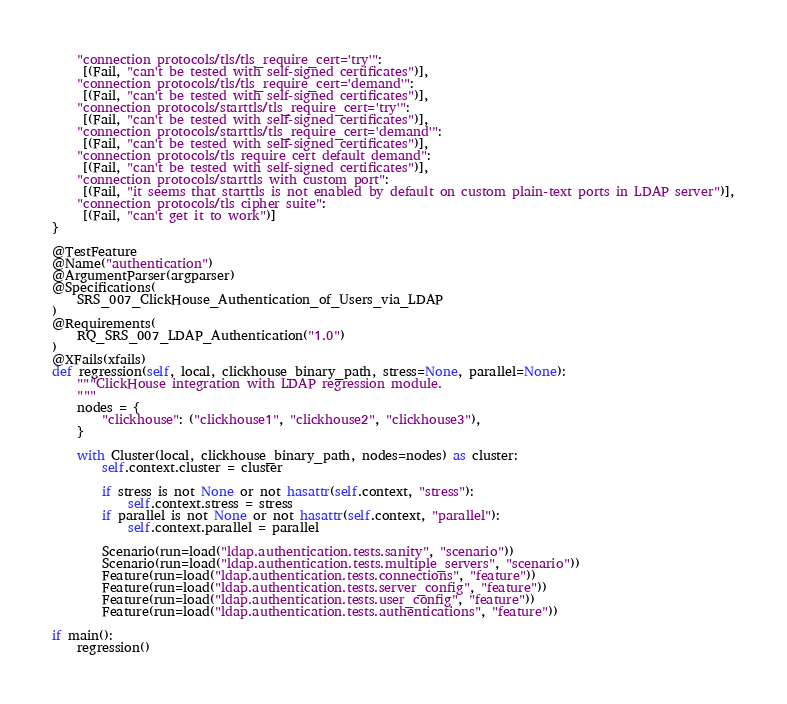<code> <loc_0><loc_0><loc_500><loc_500><_Python_>    "connection protocols/tls/tls_require_cert='try'":
     [(Fail, "can't be tested with self-signed certificates")],
    "connection protocols/tls/tls_require_cert='demand'":
     [(Fail, "can't be tested with self-signed certificates")],
    "connection protocols/starttls/tls_require_cert='try'":
     [(Fail, "can't be tested with self-signed certificates")],
    "connection protocols/starttls/tls_require_cert='demand'":
     [(Fail, "can't be tested with self-signed certificates")],
    "connection protocols/tls require cert default demand":
     [(Fail, "can't be tested with self-signed certificates")],
    "connection protocols/starttls with custom port":
     [(Fail, "it seems that starttls is not enabled by default on custom plain-text ports in LDAP server")],
    "connection protocols/tls cipher suite":
     [(Fail, "can't get it to work")]
}

@TestFeature
@Name("authentication")
@ArgumentParser(argparser)
@Specifications(
    SRS_007_ClickHouse_Authentication_of_Users_via_LDAP
)
@Requirements(
    RQ_SRS_007_LDAP_Authentication("1.0")
)
@XFails(xfails)
def regression(self, local, clickhouse_binary_path, stress=None, parallel=None):
    """ClickHouse integration with LDAP regression module.
    """
    nodes = {
        "clickhouse": ("clickhouse1", "clickhouse2", "clickhouse3"),
    }

    with Cluster(local, clickhouse_binary_path, nodes=nodes) as cluster:
        self.context.cluster = cluster

        if stress is not None or not hasattr(self.context, "stress"):
            self.context.stress = stress
        if parallel is not None or not hasattr(self.context, "parallel"):
            self.context.parallel = parallel

        Scenario(run=load("ldap.authentication.tests.sanity", "scenario"))
        Scenario(run=load("ldap.authentication.tests.multiple_servers", "scenario"))
        Feature(run=load("ldap.authentication.tests.connections", "feature"))
        Feature(run=load("ldap.authentication.tests.server_config", "feature"))
        Feature(run=load("ldap.authentication.tests.user_config", "feature"))
        Feature(run=load("ldap.authentication.tests.authentications", "feature"))

if main():
    regression()
</code> 